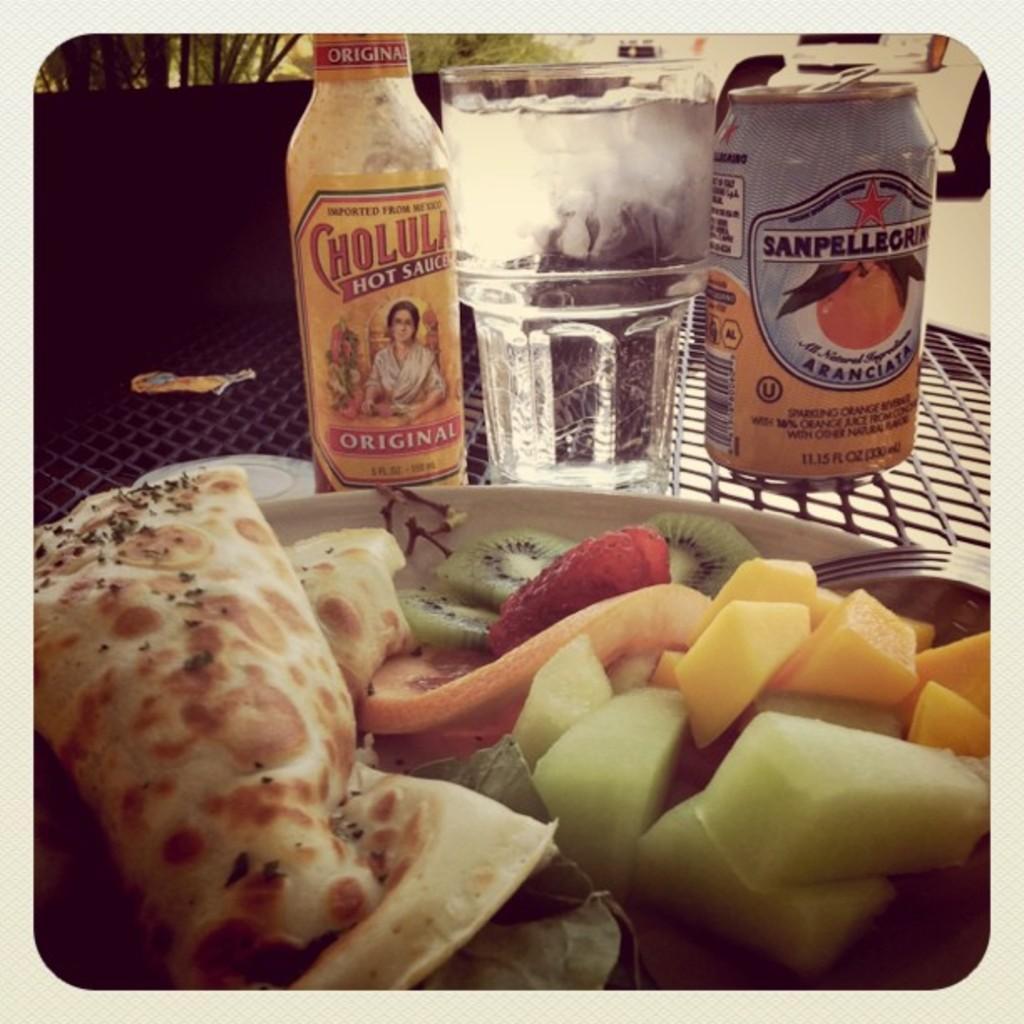In one or two sentences, can you explain what this image depicts? In this image, there is a table few items are placed on it. At the background, we can see some plant. On right side, we can see white color. 